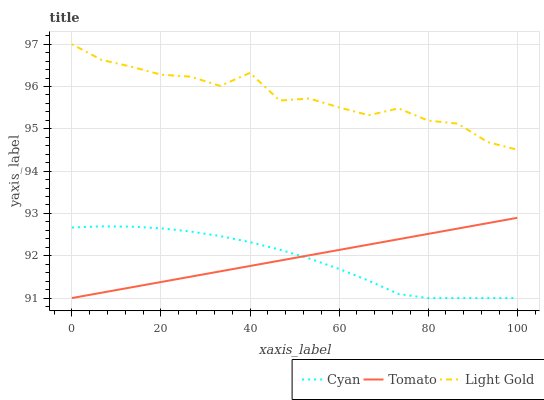Does Cyan have the minimum area under the curve?
Answer yes or no. Yes. Does Light Gold have the maximum area under the curve?
Answer yes or no. Yes. Does Light Gold have the minimum area under the curve?
Answer yes or no. No. Does Cyan have the maximum area under the curve?
Answer yes or no. No. Is Tomato the smoothest?
Answer yes or no. Yes. Is Light Gold the roughest?
Answer yes or no. Yes. Is Cyan the smoothest?
Answer yes or no. No. Is Cyan the roughest?
Answer yes or no. No. Does Tomato have the lowest value?
Answer yes or no. Yes. Does Light Gold have the lowest value?
Answer yes or no. No. Does Light Gold have the highest value?
Answer yes or no. Yes. Does Cyan have the highest value?
Answer yes or no. No. Is Cyan less than Light Gold?
Answer yes or no. Yes. Is Light Gold greater than Tomato?
Answer yes or no. Yes. Does Tomato intersect Cyan?
Answer yes or no. Yes. Is Tomato less than Cyan?
Answer yes or no. No. Is Tomato greater than Cyan?
Answer yes or no. No. Does Cyan intersect Light Gold?
Answer yes or no. No. 